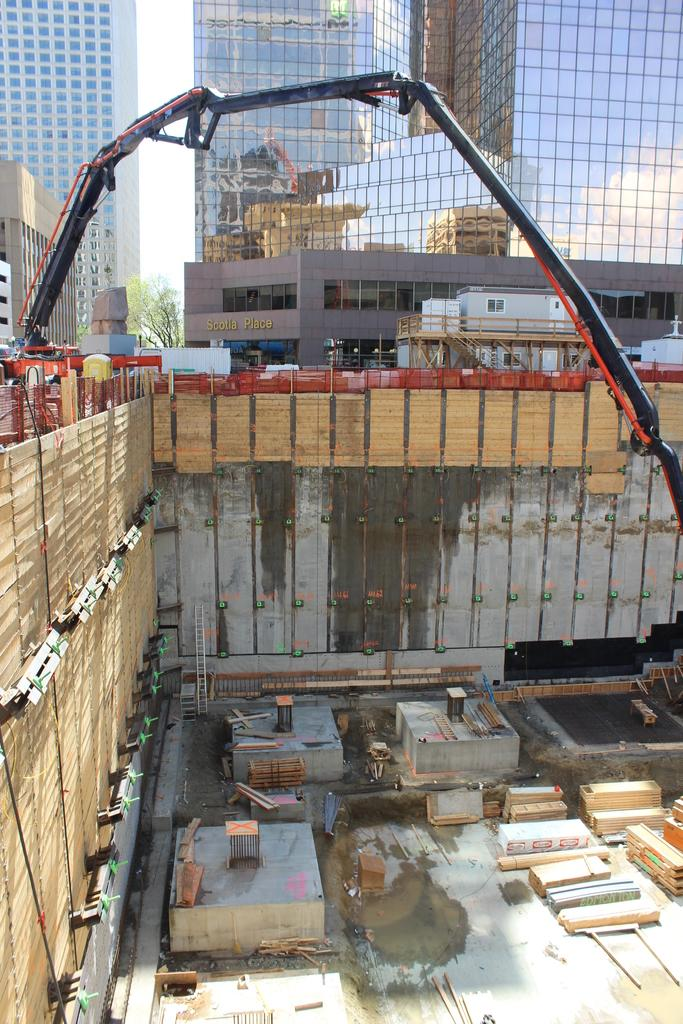What type of fence is in the image? There is a wooden fence in the image. Can you describe any specific features of the fence? A proclinear (possibly a typo for "protruding linear") is visible in the fence is visible in the image. What structures can be seen at the top of the image? There are buildings visible at the top of the image. What type of objects are on the floor in the image? Wooden objects are present on the floor in the image. What type of religious ceremony is taking place in the image? There is no indication of a religious ceremony in the image; it primarily features a wooden fence, a proclinear, buildings, and wooden objects on the floor. 